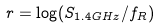<formula> <loc_0><loc_0><loc_500><loc_500>r = \log ( S _ { 1 . 4 G H z } / f _ { R } )</formula> 